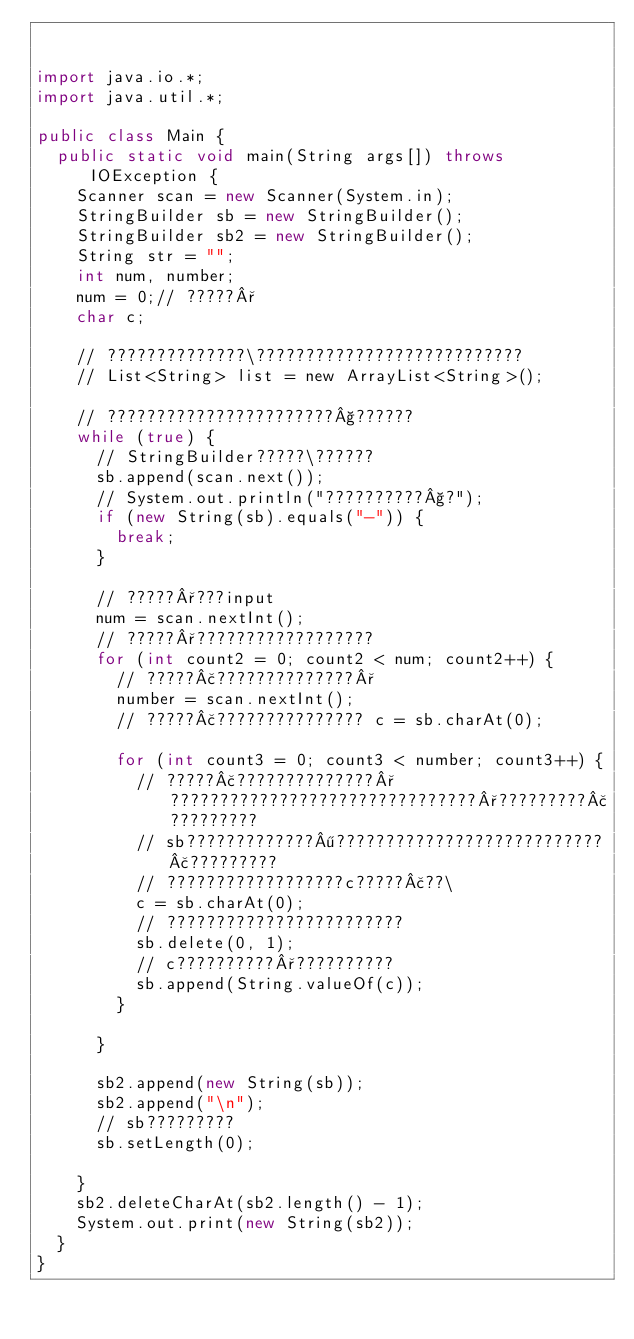Convert code to text. <code><loc_0><loc_0><loc_500><loc_500><_Java_>

import java.io.*;
import java.util.*;

public class Main {
	public static void main(String args[]) throws IOException {
		Scanner scan = new Scanner(System.in);
		StringBuilder sb = new StringBuilder();
		StringBuilder sb2 = new StringBuilder();
		String str = "";
		int num, number;
		num = 0;// ?????°
		char c;

		// ??????????????\???????????????????????????
		// List<String> list = new ArrayList<String>();

		// ???????????????????????§??????
		while (true) {
			// StringBuilder?????\??????
			sb.append(scan.next());
			// System.out.println("??????????§?");
			if (new String(sb).equals("-")) {
				break;
			}

			// ?????°???input
			num = scan.nextInt();
			// ?????°??????????????????
			for (int count2 = 0; count2 < num; count2++) {
				// ?????£??????????????°
				number = scan.nextInt();
				// ?????£??????????????? c = sb.charAt(0);

				for (int count3 = 0; count3 < number; count3++) {
					// ?????£??????????????°???????????????????????????????°?????????£?????????
					// sb?????????????¶???????????????????????????£?????????
					// ??????????????????c?????£??\
					c = sb.charAt(0);
					// ????????????????????????
					sb.delete(0, 1);
					// c??????????°??????????
					sb.append(String.valueOf(c));
				}

			}

			sb2.append(new String(sb));
			sb2.append("\n");
			// sb?????????
			sb.setLength(0);

		}
		sb2.deleteCharAt(sb2.length() - 1);
		System.out.print(new String(sb2));
	}
}</code> 